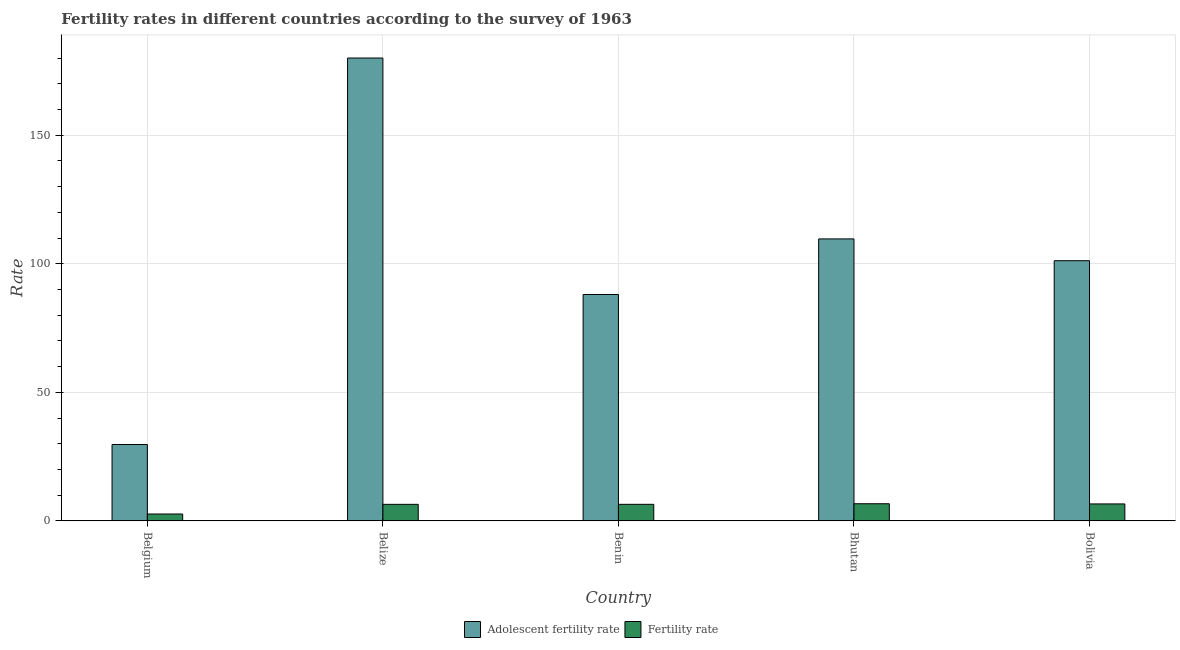How many different coloured bars are there?
Ensure brevity in your answer.  2. How many groups of bars are there?
Offer a very short reply. 5. Are the number of bars per tick equal to the number of legend labels?
Make the answer very short. Yes. What is the label of the 2nd group of bars from the left?
Offer a very short reply. Belize. In how many cases, is the number of bars for a given country not equal to the number of legend labels?
Provide a short and direct response. 0. What is the adolescent fertility rate in Bolivia?
Your response must be concise. 101.2. Across all countries, what is the maximum fertility rate?
Offer a terse response. 6.67. Across all countries, what is the minimum adolescent fertility rate?
Your answer should be compact. 29.72. In which country was the adolescent fertility rate maximum?
Provide a succinct answer. Belize. In which country was the fertility rate minimum?
Offer a terse response. Belgium. What is the total fertility rate in the graph?
Provide a succinct answer. 28.83. What is the difference between the adolescent fertility rate in Belgium and that in Benin?
Offer a terse response. -58.34. What is the difference between the fertility rate in Benin and the adolescent fertility rate in Belgium?
Offer a terse response. -23.27. What is the average fertility rate per country?
Provide a succinct answer. 5.77. What is the difference between the fertility rate and adolescent fertility rate in Bhutan?
Your answer should be very brief. -103.01. In how many countries, is the fertility rate greater than 160 ?
Your answer should be very brief. 0. What is the ratio of the fertility rate in Belize to that in Bhutan?
Offer a very short reply. 0.97. Is the fertility rate in Benin less than that in Bhutan?
Give a very brief answer. Yes. What is the difference between the highest and the second highest adolescent fertility rate?
Your answer should be very brief. 70.36. What is the difference between the highest and the lowest adolescent fertility rate?
Provide a succinct answer. 150.32. Is the sum of the adolescent fertility rate in Belgium and Bolivia greater than the maximum fertility rate across all countries?
Ensure brevity in your answer.  Yes. What does the 2nd bar from the left in Belize represents?
Provide a succinct answer. Fertility rate. What does the 2nd bar from the right in Bolivia represents?
Your answer should be very brief. Adolescent fertility rate. How many countries are there in the graph?
Offer a terse response. 5. Where does the legend appear in the graph?
Keep it short and to the point. Bottom center. How many legend labels are there?
Your answer should be very brief. 2. How are the legend labels stacked?
Provide a short and direct response. Horizontal. What is the title of the graph?
Give a very brief answer. Fertility rates in different countries according to the survey of 1963. Does "Net savings(excluding particulate emission damage)" appear as one of the legend labels in the graph?
Your answer should be compact. No. What is the label or title of the X-axis?
Your answer should be compact. Country. What is the label or title of the Y-axis?
Your answer should be very brief. Rate. What is the Rate of Adolescent fertility rate in Belgium?
Your response must be concise. 29.72. What is the Rate of Fertility rate in Belgium?
Provide a short and direct response. 2.68. What is the Rate in Adolescent fertility rate in Belize?
Offer a terse response. 180.04. What is the Rate in Fertility rate in Belize?
Provide a succinct answer. 6.44. What is the Rate of Adolescent fertility rate in Benin?
Give a very brief answer. 88.06. What is the Rate in Fertility rate in Benin?
Offer a terse response. 6.45. What is the Rate of Adolescent fertility rate in Bhutan?
Your answer should be compact. 109.68. What is the Rate of Fertility rate in Bhutan?
Your response must be concise. 6.67. What is the Rate of Adolescent fertility rate in Bolivia?
Ensure brevity in your answer.  101.2. What is the Rate of Fertility rate in Bolivia?
Provide a short and direct response. 6.6. Across all countries, what is the maximum Rate of Adolescent fertility rate?
Keep it short and to the point. 180.04. Across all countries, what is the maximum Rate of Fertility rate?
Keep it short and to the point. 6.67. Across all countries, what is the minimum Rate of Adolescent fertility rate?
Give a very brief answer. 29.72. Across all countries, what is the minimum Rate in Fertility rate?
Your answer should be very brief. 2.68. What is the total Rate in Adolescent fertility rate in the graph?
Give a very brief answer. 508.7. What is the total Rate of Fertility rate in the graph?
Offer a terse response. 28.83. What is the difference between the Rate of Adolescent fertility rate in Belgium and that in Belize?
Give a very brief answer. -150.32. What is the difference between the Rate in Fertility rate in Belgium and that in Belize?
Offer a very short reply. -3.76. What is the difference between the Rate in Adolescent fertility rate in Belgium and that in Benin?
Your answer should be very brief. -58.34. What is the difference between the Rate of Fertility rate in Belgium and that in Benin?
Offer a terse response. -3.77. What is the difference between the Rate in Adolescent fertility rate in Belgium and that in Bhutan?
Give a very brief answer. -79.96. What is the difference between the Rate in Fertility rate in Belgium and that in Bhutan?
Your response must be concise. -3.99. What is the difference between the Rate of Adolescent fertility rate in Belgium and that in Bolivia?
Offer a terse response. -71.48. What is the difference between the Rate in Fertility rate in Belgium and that in Bolivia?
Your response must be concise. -3.92. What is the difference between the Rate in Adolescent fertility rate in Belize and that in Benin?
Your answer should be compact. 91.98. What is the difference between the Rate of Fertility rate in Belize and that in Benin?
Give a very brief answer. -0.01. What is the difference between the Rate in Adolescent fertility rate in Belize and that in Bhutan?
Offer a terse response. 70.36. What is the difference between the Rate in Fertility rate in Belize and that in Bhutan?
Keep it short and to the point. -0.23. What is the difference between the Rate of Adolescent fertility rate in Belize and that in Bolivia?
Provide a short and direct response. 78.84. What is the difference between the Rate of Fertility rate in Belize and that in Bolivia?
Offer a very short reply. -0.16. What is the difference between the Rate of Adolescent fertility rate in Benin and that in Bhutan?
Offer a terse response. -21.62. What is the difference between the Rate of Fertility rate in Benin and that in Bhutan?
Your answer should be very brief. -0.22. What is the difference between the Rate in Adolescent fertility rate in Benin and that in Bolivia?
Keep it short and to the point. -13.14. What is the difference between the Rate of Adolescent fertility rate in Bhutan and that in Bolivia?
Your response must be concise. 8.48. What is the difference between the Rate of Fertility rate in Bhutan and that in Bolivia?
Ensure brevity in your answer.  0.07. What is the difference between the Rate in Adolescent fertility rate in Belgium and the Rate in Fertility rate in Belize?
Make the answer very short. 23.28. What is the difference between the Rate of Adolescent fertility rate in Belgium and the Rate of Fertility rate in Benin?
Offer a terse response. 23.27. What is the difference between the Rate of Adolescent fertility rate in Belgium and the Rate of Fertility rate in Bhutan?
Your answer should be very brief. 23.05. What is the difference between the Rate in Adolescent fertility rate in Belgium and the Rate in Fertility rate in Bolivia?
Your answer should be compact. 23.12. What is the difference between the Rate of Adolescent fertility rate in Belize and the Rate of Fertility rate in Benin?
Make the answer very short. 173.59. What is the difference between the Rate of Adolescent fertility rate in Belize and the Rate of Fertility rate in Bhutan?
Keep it short and to the point. 173.37. What is the difference between the Rate in Adolescent fertility rate in Belize and the Rate in Fertility rate in Bolivia?
Give a very brief answer. 173.44. What is the difference between the Rate of Adolescent fertility rate in Benin and the Rate of Fertility rate in Bhutan?
Give a very brief answer. 81.39. What is the difference between the Rate of Adolescent fertility rate in Benin and the Rate of Fertility rate in Bolivia?
Your response must be concise. 81.46. What is the difference between the Rate of Adolescent fertility rate in Bhutan and the Rate of Fertility rate in Bolivia?
Give a very brief answer. 103.08. What is the average Rate in Adolescent fertility rate per country?
Your answer should be very brief. 101.74. What is the average Rate in Fertility rate per country?
Ensure brevity in your answer.  5.77. What is the difference between the Rate of Adolescent fertility rate and Rate of Fertility rate in Belgium?
Ensure brevity in your answer.  27.04. What is the difference between the Rate in Adolescent fertility rate and Rate in Fertility rate in Belize?
Provide a succinct answer. 173.6. What is the difference between the Rate of Adolescent fertility rate and Rate of Fertility rate in Benin?
Give a very brief answer. 81.61. What is the difference between the Rate of Adolescent fertility rate and Rate of Fertility rate in Bhutan?
Keep it short and to the point. 103.01. What is the difference between the Rate in Adolescent fertility rate and Rate in Fertility rate in Bolivia?
Offer a terse response. 94.6. What is the ratio of the Rate of Adolescent fertility rate in Belgium to that in Belize?
Your answer should be very brief. 0.17. What is the ratio of the Rate of Fertility rate in Belgium to that in Belize?
Your answer should be compact. 0.42. What is the ratio of the Rate of Adolescent fertility rate in Belgium to that in Benin?
Provide a short and direct response. 0.34. What is the ratio of the Rate in Fertility rate in Belgium to that in Benin?
Provide a succinct answer. 0.42. What is the ratio of the Rate of Adolescent fertility rate in Belgium to that in Bhutan?
Ensure brevity in your answer.  0.27. What is the ratio of the Rate in Fertility rate in Belgium to that in Bhutan?
Ensure brevity in your answer.  0.4. What is the ratio of the Rate in Adolescent fertility rate in Belgium to that in Bolivia?
Ensure brevity in your answer.  0.29. What is the ratio of the Rate of Fertility rate in Belgium to that in Bolivia?
Keep it short and to the point. 0.41. What is the ratio of the Rate of Adolescent fertility rate in Belize to that in Benin?
Provide a succinct answer. 2.04. What is the ratio of the Rate in Adolescent fertility rate in Belize to that in Bhutan?
Ensure brevity in your answer.  1.64. What is the ratio of the Rate in Fertility rate in Belize to that in Bhutan?
Ensure brevity in your answer.  0.97. What is the ratio of the Rate of Adolescent fertility rate in Belize to that in Bolivia?
Ensure brevity in your answer.  1.78. What is the ratio of the Rate of Fertility rate in Belize to that in Bolivia?
Make the answer very short. 0.98. What is the ratio of the Rate in Adolescent fertility rate in Benin to that in Bhutan?
Your response must be concise. 0.8. What is the ratio of the Rate of Fertility rate in Benin to that in Bhutan?
Your answer should be very brief. 0.97. What is the ratio of the Rate of Adolescent fertility rate in Benin to that in Bolivia?
Provide a succinct answer. 0.87. What is the ratio of the Rate in Fertility rate in Benin to that in Bolivia?
Keep it short and to the point. 0.98. What is the ratio of the Rate in Adolescent fertility rate in Bhutan to that in Bolivia?
Provide a short and direct response. 1.08. What is the ratio of the Rate in Fertility rate in Bhutan to that in Bolivia?
Make the answer very short. 1.01. What is the difference between the highest and the second highest Rate of Adolescent fertility rate?
Offer a very short reply. 70.36. What is the difference between the highest and the second highest Rate in Fertility rate?
Give a very brief answer. 0.07. What is the difference between the highest and the lowest Rate in Adolescent fertility rate?
Your response must be concise. 150.32. What is the difference between the highest and the lowest Rate in Fertility rate?
Ensure brevity in your answer.  3.99. 